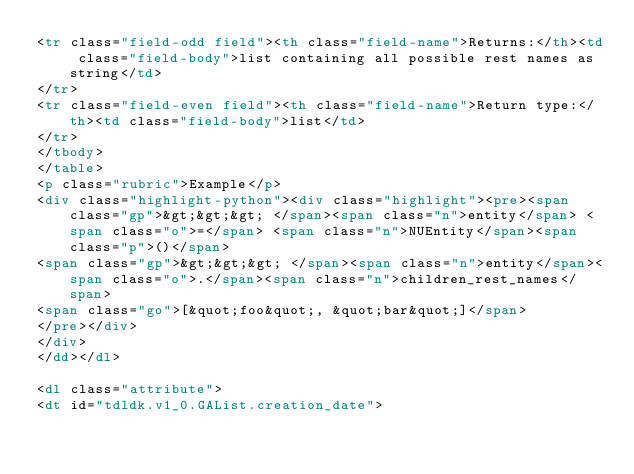<code> <loc_0><loc_0><loc_500><loc_500><_HTML_><tr class="field-odd field"><th class="field-name">Returns:</th><td class="field-body">list containing all possible rest names as string</td>
</tr>
<tr class="field-even field"><th class="field-name">Return type:</th><td class="field-body">list</td>
</tr>
</tbody>
</table>
<p class="rubric">Example</p>
<div class="highlight-python"><div class="highlight"><pre><span class="gp">&gt;&gt;&gt; </span><span class="n">entity</span> <span class="o">=</span> <span class="n">NUEntity</span><span class="p">()</span>
<span class="gp">&gt;&gt;&gt; </span><span class="n">entity</span><span class="o">.</span><span class="n">children_rest_names</span>
<span class="go">[&quot;foo&quot;, &quot;bar&quot;]</span>
</pre></div>
</div>
</dd></dl>

<dl class="attribute">
<dt id="tdldk.v1_0.GAList.creation_date"></code> 